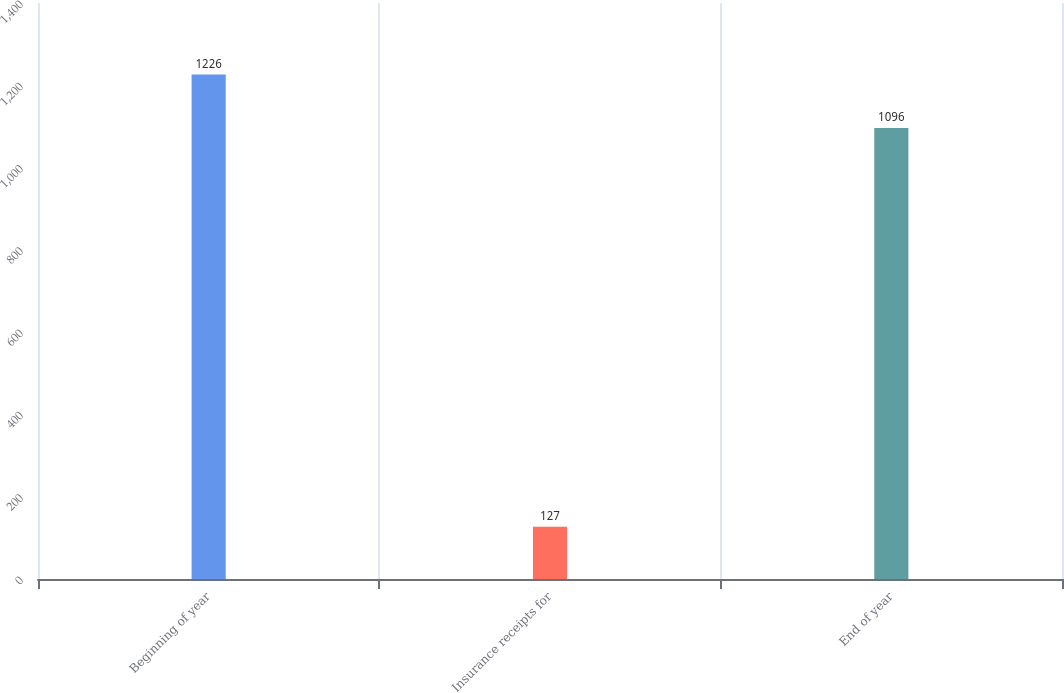<chart> <loc_0><loc_0><loc_500><loc_500><bar_chart><fcel>Beginning of year<fcel>Insurance receipts for<fcel>End of year<nl><fcel>1226<fcel>127<fcel>1096<nl></chart> 